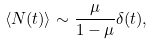Convert formula to latex. <formula><loc_0><loc_0><loc_500><loc_500>\langle N ( t ) \rangle \sim \frac { \mu } { 1 - \mu } \delta ( t ) ,</formula> 